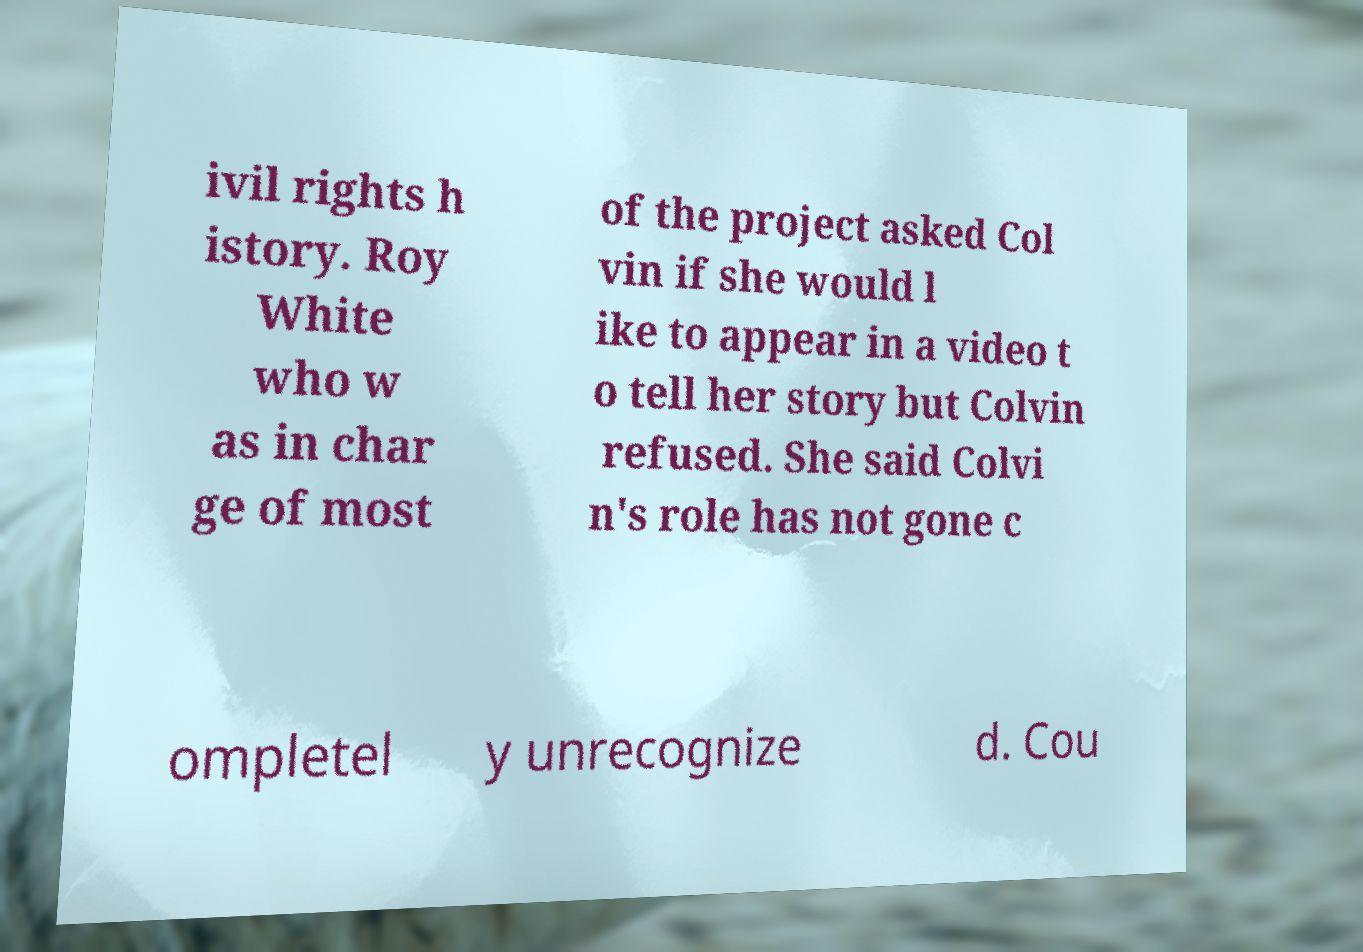Could you extract and type out the text from this image? ivil rights h istory. Roy White who w as in char ge of most of the project asked Col vin if she would l ike to appear in a video t o tell her story but Colvin refused. She said Colvi n's role has not gone c ompletel y unrecognize d. Cou 